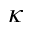<formula> <loc_0><loc_0><loc_500><loc_500>\kappa</formula> 